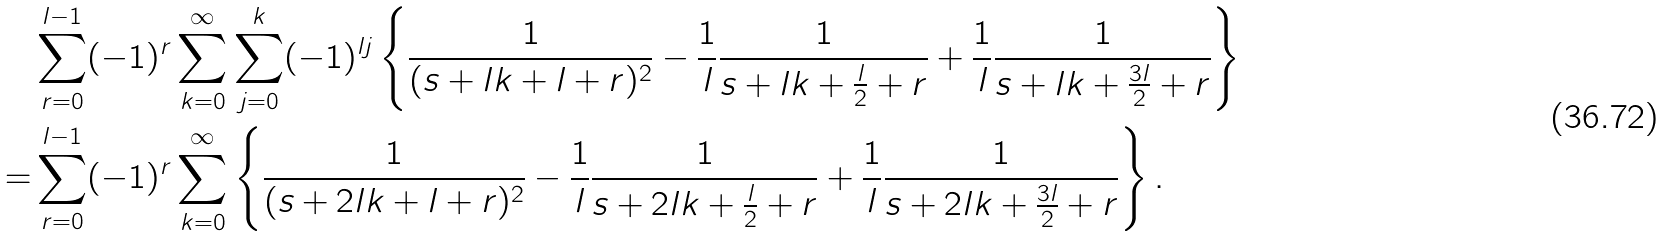<formula> <loc_0><loc_0><loc_500><loc_500>& \sum _ { r = 0 } ^ { l - 1 } ( - 1 ) ^ { r } \sum _ { k = 0 } ^ { \infty } \sum _ { j = 0 } ^ { k } ( - 1 ) ^ { l j } \left \{ \frac { 1 } { ( s + l k + l + r ) ^ { 2 } } - \frac { 1 } { l } \frac { 1 } { s + l k + \frac { l } { 2 } + r } + \frac { 1 } { l } \frac { 1 } { s + l k + \frac { 3 l } { 2 } + r } \right \} \\ = & \sum _ { r = 0 } ^ { l - 1 } ( - 1 ) ^ { r } \sum _ { k = 0 } ^ { \infty } \left \{ \frac { 1 } { ( s + 2 l k + l + r ) ^ { 2 } } - \frac { 1 } { l } \frac { 1 } { s + 2 l k + \frac { l } { 2 } + r } + \frac { 1 } { l } \frac { 1 } { s + 2 l k + \frac { 3 l } { 2 } + r } \right \} .</formula> 